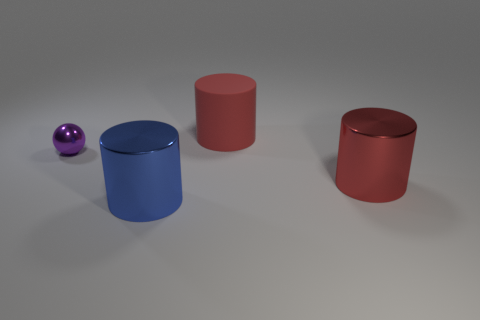Is there anything else that is the same size as the purple thing?
Offer a very short reply. No. Is the color of the big shiny object behind the blue metal thing the same as the cylinder behind the tiny purple metallic object?
Provide a succinct answer. Yes. Is there a large cylinder that has the same material as the small purple object?
Make the answer very short. Yes. What number of red objects are either matte things or shiny objects?
Ensure brevity in your answer.  2. Are there more blue shiny objects that are on the right side of the purple thing than big yellow metal blocks?
Provide a short and direct response. Yes. Is the blue metal thing the same size as the matte cylinder?
Provide a short and direct response. Yes. The big thing that is made of the same material as the big blue cylinder is what color?
Keep it short and to the point. Red. Are there an equal number of metal balls that are right of the rubber cylinder and large red matte objects on the left side of the small purple sphere?
Keep it short and to the point. Yes. There is a large thing that is right of the cylinder behind the purple thing; what is its shape?
Offer a terse response. Cylinder. There is a large blue object that is the same shape as the red metallic object; what is its material?
Offer a terse response. Metal. 